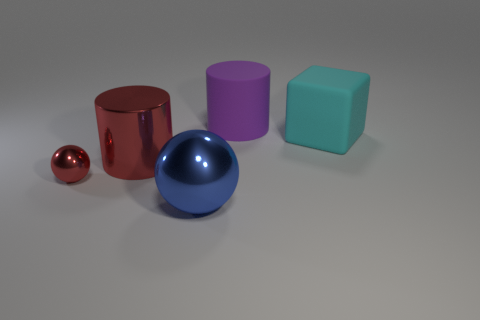Is there any other thing that has the same material as the cyan thing?
Offer a terse response. Yes. What number of other objects are there of the same size as the red sphere?
Your answer should be compact. 0. Are there any big objects that have the same color as the small metallic object?
Make the answer very short. Yes. There is a object that is in front of the object on the left side of the red cylinder; what is its color?
Ensure brevity in your answer.  Blue. Are there fewer big red metallic cylinders to the left of the purple cylinder than small shiny things that are to the right of the large shiny cylinder?
Your answer should be compact. No. Does the cyan block have the same size as the blue metal thing?
Your response must be concise. Yes. There is a big thing that is right of the large red shiny thing and in front of the cyan object; what is its shape?
Ensure brevity in your answer.  Sphere. How many small balls have the same material as the large blue sphere?
Provide a short and direct response. 1. There is a big cylinder in front of the cyan rubber object; what number of big things are in front of it?
Your answer should be compact. 1. The big metallic thing that is in front of the red metal thing that is right of the thing that is on the left side of the red cylinder is what shape?
Give a very brief answer. Sphere. 